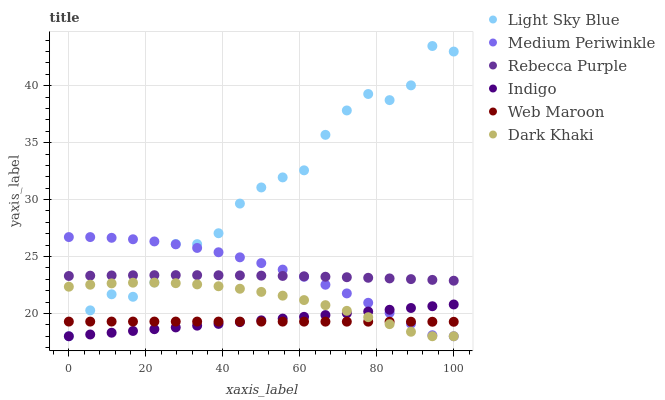Does Web Maroon have the minimum area under the curve?
Answer yes or no. Yes. Does Light Sky Blue have the maximum area under the curve?
Answer yes or no. Yes. Does Medium Periwinkle have the minimum area under the curve?
Answer yes or no. No. Does Medium Periwinkle have the maximum area under the curve?
Answer yes or no. No. Is Indigo the smoothest?
Answer yes or no. Yes. Is Light Sky Blue the roughest?
Answer yes or no. Yes. Is Web Maroon the smoothest?
Answer yes or no. No. Is Web Maroon the roughest?
Answer yes or no. No. Does Indigo have the lowest value?
Answer yes or no. Yes. Does Web Maroon have the lowest value?
Answer yes or no. No. Does Light Sky Blue have the highest value?
Answer yes or no. Yes. Does Medium Periwinkle have the highest value?
Answer yes or no. No. Is Web Maroon less than Rebecca Purple?
Answer yes or no. Yes. Is Rebecca Purple greater than Indigo?
Answer yes or no. Yes. Does Dark Khaki intersect Web Maroon?
Answer yes or no. Yes. Is Dark Khaki less than Web Maroon?
Answer yes or no. No. Is Dark Khaki greater than Web Maroon?
Answer yes or no. No. Does Web Maroon intersect Rebecca Purple?
Answer yes or no. No. 